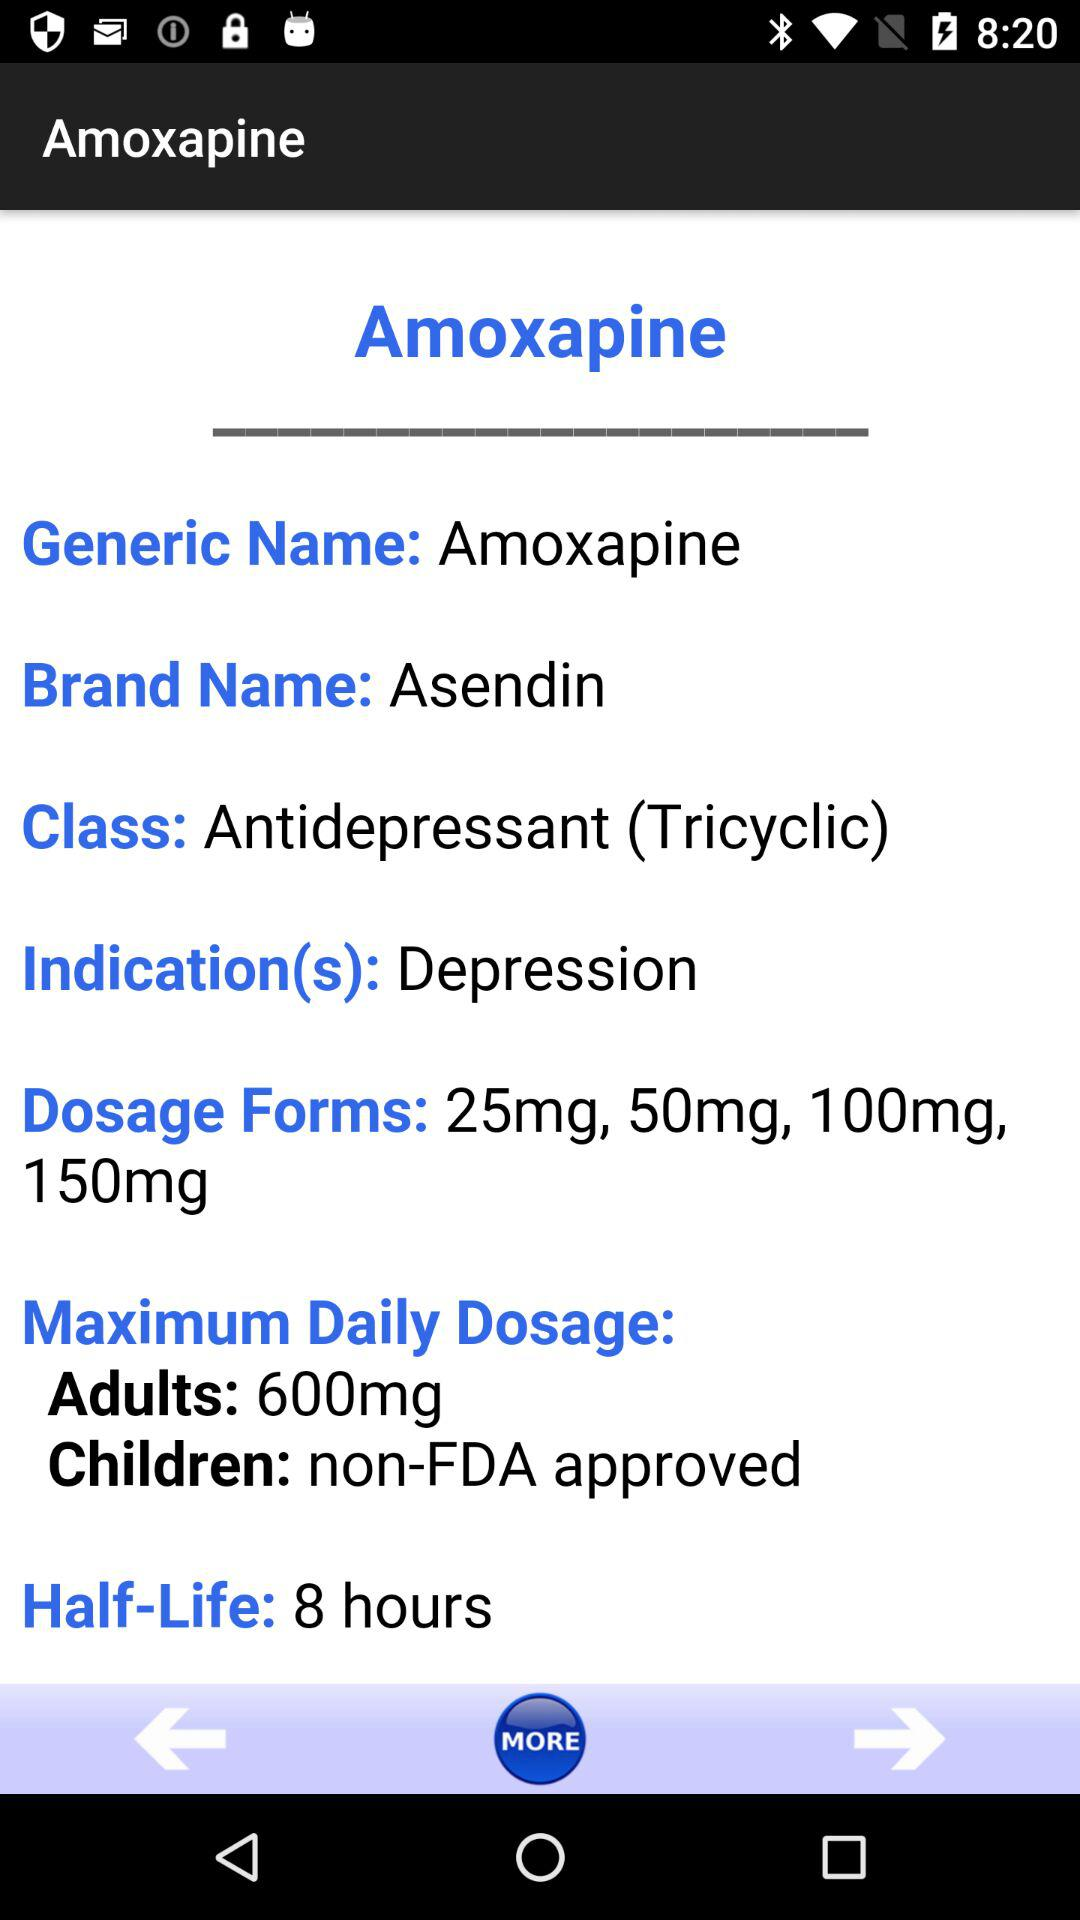What is the half-life? The half-life is 8 hours. 